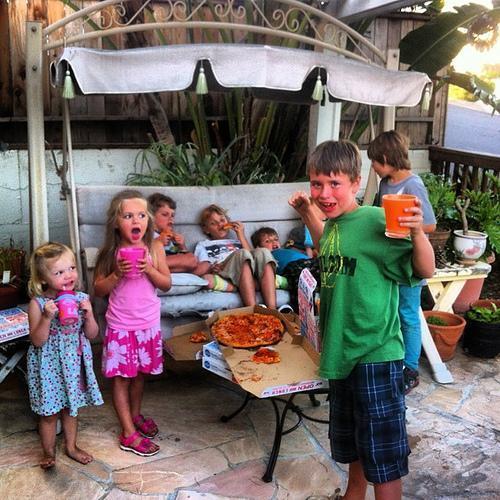How many kids are there?
Give a very brief answer. 7. 